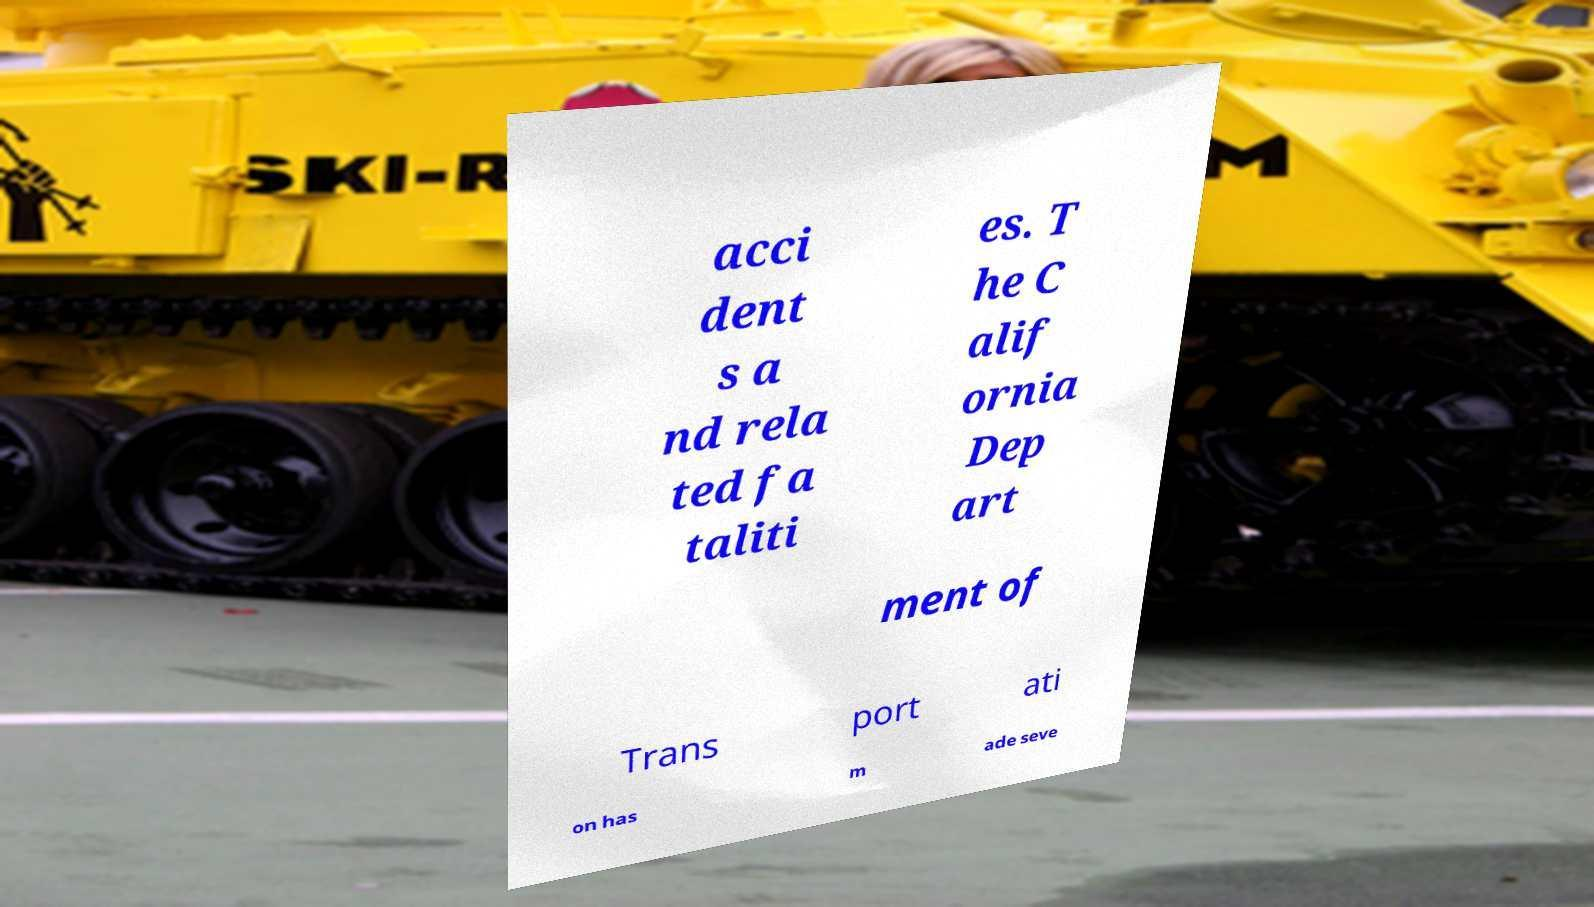Could you assist in decoding the text presented in this image and type it out clearly? acci dent s a nd rela ted fa taliti es. T he C alif ornia Dep art ment of Trans port ati on has m ade seve 